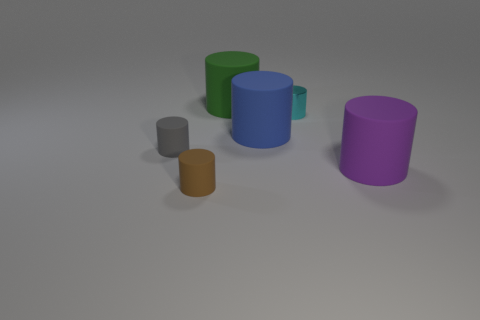Subtract all large purple rubber cylinders. How many cylinders are left? 5 Subtract all brown cylinders. How many cylinders are left? 5 Subtract all blue cylinders. Subtract all gray cubes. How many cylinders are left? 5 Add 1 small metallic cylinders. How many objects exist? 7 Add 5 small purple rubber things. How many small purple rubber things exist? 5 Subtract 0 brown cubes. How many objects are left? 6 Subtract all small cyan cylinders. Subtract all tiny red spheres. How many objects are left? 5 Add 5 cyan things. How many cyan things are left? 6 